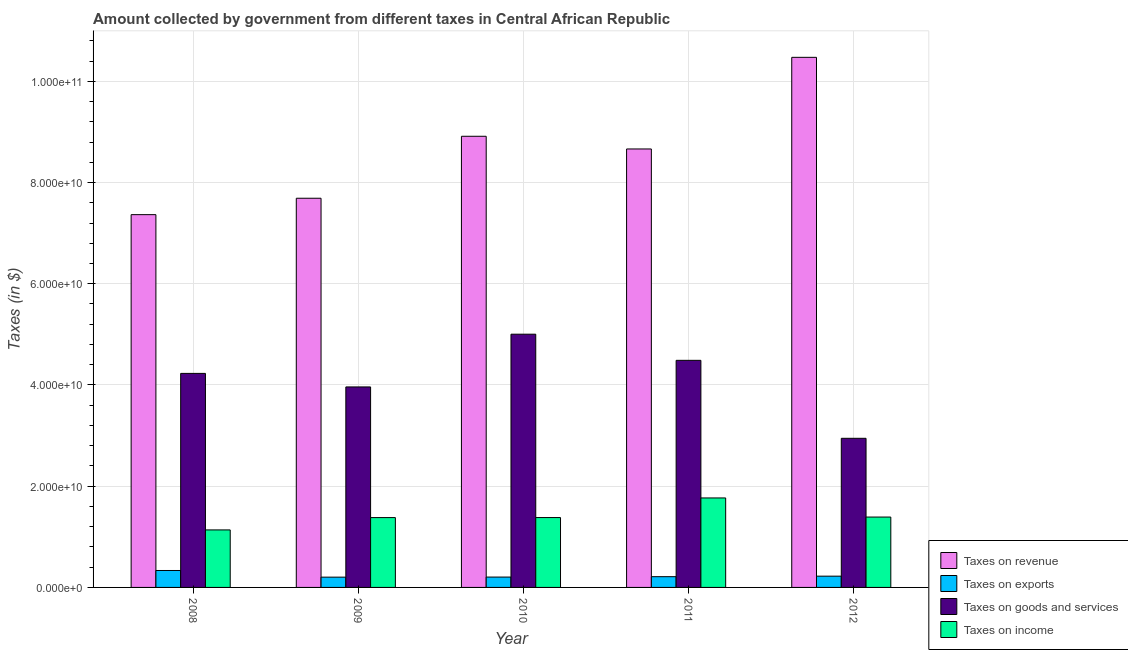How many bars are there on the 5th tick from the left?
Give a very brief answer. 4. How many bars are there on the 1st tick from the right?
Provide a succinct answer. 4. What is the label of the 4th group of bars from the left?
Your answer should be compact. 2011. In how many cases, is the number of bars for a given year not equal to the number of legend labels?
Your response must be concise. 0. What is the amount collected as tax on income in 2012?
Make the answer very short. 1.39e+1. Across all years, what is the maximum amount collected as tax on income?
Your answer should be very brief. 1.77e+1. Across all years, what is the minimum amount collected as tax on goods?
Offer a terse response. 2.95e+1. In which year was the amount collected as tax on goods maximum?
Your response must be concise. 2010. In which year was the amount collected as tax on goods minimum?
Provide a succinct answer. 2012. What is the total amount collected as tax on revenue in the graph?
Provide a succinct answer. 4.31e+11. What is the difference between the amount collected as tax on goods in 2008 and that in 2012?
Ensure brevity in your answer.  1.28e+1. What is the difference between the amount collected as tax on exports in 2008 and the amount collected as tax on revenue in 2010?
Your response must be concise. 1.30e+09. What is the average amount collected as tax on income per year?
Offer a very short reply. 1.41e+1. In the year 2011, what is the difference between the amount collected as tax on revenue and amount collected as tax on income?
Your response must be concise. 0. In how many years, is the amount collected as tax on exports greater than 76000000000 $?
Make the answer very short. 0. What is the ratio of the amount collected as tax on goods in 2011 to that in 2012?
Offer a very short reply. 1.52. Is the amount collected as tax on income in 2009 less than that in 2010?
Provide a short and direct response. Yes. What is the difference between the highest and the second highest amount collected as tax on revenue?
Make the answer very short. 1.56e+1. What is the difference between the highest and the lowest amount collected as tax on exports?
Offer a very short reply. 1.32e+09. What does the 1st bar from the left in 2009 represents?
Keep it short and to the point. Taxes on revenue. What does the 3rd bar from the right in 2010 represents?
Provide a short and direct response. Taxes on exports. Is it the case that in every year, the sum of the amount collected as tax on revenue and amount collected as tax on exports is greater than the amount collected as tax on goods?
Offer a terse response. Yes. How many bars are there?
Keep it short and to the point. 20. Are the values on the major ticks of Y-axis written in scientific E-notation?
Your response must be concise. Yes. Where does the legend appear in the graph?
Keep it short and to the point. Bottom right. How many legend labels are there?
Give a very brief answer. 4. What is the title of the graph?
Make the answer very short. Amount collected by government from different taxes in Central African Republic. Does "Austria" appear as one of the legend labels in the graph?
Provide a succinct answer. No. What is the label or title of the X-axis?
Your answer should be very brief. Year. What is the label or title of the Y-axis?
Provide a succinct answer. Taxes (in $). What is the Taxes (in $) in Taxes on revenue in 2008?
Offer a very short reply. 7.37e+1. What is the Taxes (in $) of Taxes on exports in 2008?
Your answer should be very brief. 3.35e+09. What is the Taxes (in $) in Taxes on goods and services in 2008?
Your response must be concise. 4.23e+1. What is the Taxes (in $) in Taxes on income in 2008?
Make the answer very short. 1.14e+1. What is the Taxes (in $) of Taxes on revenue in 2009?
Provide a short and direct response. 7.69e+1. What is the Taxes (in $) of Taxes on exports in 2009?
Your response must be concise. 2.03e+09. What is the Taxes (in $) of Taxes on goods and services in 2009?
Provide a short and direct response. 3.96e+1. What is the Taxes (in $) of Taxes on income in 2009?
Offer a terse response. 1.38e+1. What is the Taxes (in $) of Taxes on revenue in 2010?
Make the answer very short. 8.91e+1. What is the Taxes (in $) in Taxes on exports in 2010?
Your answer should be compact. 2.05e+09. What is the Taxes (in $) in Taxes on goods and services in 2010?
Give a very brief answer. 5.00e+1. What is the Taxes (in $) in Taxes on income in 2010?
Your answer should be compact. 1.38e+1. What is the Taxes (in $) in Taxes on revenue in 2011?
Offer a terse response. 8.66e+1. What is the Taxes (in $) of Taxes on exports in 2011?
Keep it short and to the point. 2.12e+09. What is the Taxes (in $) in Taxes on goods and services in 2011?
Provide a succinct answer. 4.49e+1. What is the Taxes (in $) of Taxes on income in 2011?
Your answer should be compact. 1.77e+1. What is the Taxes (in $) in Taxes on revenue in 2012?
Your answer should be compact. 1.05e+11. What is the Taxes (in $) of Taxes on exports in 2012?
Give a very brief answer. 2.23e+09. What is the Taxes (in $) of Taxes on goods and services in 2012?
Make the answer very short. 2.95e+1. What is the Taxes (in $) in Taxes on income in 2012?
Your answer should be very brief. 1.39e+1. Across all years, what is the maximum Taxes (in $) in Taxes on revenue?
Give a very brief answer. 1.05e+11. Across all years, what is the maximum Taxes (in $) of Taxes on exports?
Make the answer very short. 3.35e+09. Across all years, what is the maximum Taxes (in $) of Taxes on goods and services?
Your answer should be very brief. 5.00e+1. Across all years, what is the maximum Taxes (in $) of Taxes on income?
Ensure brevity in your answer.  1.77e+1. Across all years, what is the minimum Taxes (in $) of Taxes on revenue?
Offer a very short reply. 7.37e+1. Across all years, what is the minimum Taxes (in $) of Taxes on exports?
Provide a succinct answer. 2.03e+09. Across all years, what is the minimum Taxes (in $) in Taxes on goods and services?
Provide a succinct answer. 2.95e+1. Across all years, what is the minimum Taxes (in $) of Taxes on income?
Ensure brevity in your answer.  1.14e+1. What is the total Taxes (in $) of Taxes on revenue in the graph?
Keep it short and to the point. 4.31e+11. What is the total Taxes (in $) in Taxes on exports in the graph?
Your answer should be compact. 1.18e+1. What is the total Taxes (in $) of Taxes on goods and services in the graph?
Offer a very short reply. 2.06e+11. What is the total Taxes (in $) of Taxes on income in the graph?
Provide a succinct answer. 7.05e+1. What is the difference between the Taxes (in $) of Taxes on revenue in 2008 and that in 2009?
Your response must be concise. -3.24e+09. What is the difference between the Taxes (in $) of Taxes on exports in 2008 and that in 2009?
Your answer should be very brief. 1.32e+09. What is the difference between the Taxes (in $) in Taxes on goods and services in 2008 and that in 2009?
Your answer should be compact. 2.67e+09. What is the difference between the Taxes (in $) of Taxes on income in 2008 and that in 2009?
Your response must be concise. -2.44e+09. What is the difference between the Taxes (in $) of Taxes on revenue in 2008 and that in 2010?
Offer a terse response. -1.55e+1. What is the difference between the Taxes (in $) in Taxes on exports in 2008 and that in 2010?
Your answer should be compact. 1.30e+09. What is the difference between the Taxes (in $) in Taxes on goods and services in 2008 and that in 2010?
Keep it short and to the point. -7.75e+09. What is the difference between the Taxes (in $) of Taxes on income in 2008 and that in 2010?
Offer a very short reply. -2.44e+09. What is the difference between the Taxes (in $) in Taxes on revenue in 2008 and that in 2011?
Provide a succinct answer. -1.30e+1. What is the difference between the Taxes (in $) in Taxes on exports in 2008 and that in 2011?
Keep it short and to the point. 1.22e+09. What is the difference between the Taxes (in $) of Taxes on goods and services in 2008 and that in 2011?
Make the answer very short. -2.58e+09. What is the difference between the Taxes (in $) of Taxes on income in 2008 and that in 2011?
Make the answer very short. -6.32e+09. What is the difference between the Taxes (in $) in Taxes on revenue in 2008 and that in 2012?
Your response must be concise. -3.11e+1. What is the difference between the Taxes (in $) in Taxes on exports in 2008 and that in 2012?
Provide a short and direct response. 1.12e+09. What is the difference between the Taxes (in $) of Taxes on goods and services in 2008 and that in 2012?
Your answer should be compact. 1.28e+1. What is the difference between the Taxes (in $) of Taxes on income in 2008 and that in 2012?
Provide a short and direct response. -2.54e+09. What is the difference between the Taxes (in $) of Taxes on revenue in 2009 and that in 2010?
Your answer should be compact. -1.22e+1. What is the difference between the Taxes (in $) in Taxes on exports in 2009 and that in 2010?
Your answer should be very brief. -1.71e+07. What is the difference between the Taxes (in $) of Taxes on goods and services in 2009 and that in 2010?
Keep it short and to the point. -1.04e+1. What is the difference between the Taxes (in $) of Taxes on income in 2009 and that in 2010?
Ensure brevity in your answer.  -7.21e+06. What is the difference between the Taxes (in $) in Taxes on revenue in 2009 and that in 2011?
Your answer should be very brief. -9.74e+09. What is the difference between the Taxes (in $) of Taxes on exports in 2009 and that in 2011?
Your answer should be compact. -9.30e+07. What is the difference between the Taxes (in $) of Taxes on goods and services in 2009 and that in 2011?
Ensure brevity in your answer.  -5.25e+09. What is the difference between the Taxes (in $) in Taxes on income in 2009 and that in 2011?
Provide a short and direct response. -3.88e+09. What is the difference between the Taxes (in $) in Taxes on revenue in 2009 and that in 2012?
Provide a short and direct response. -2.78e+1. What is the difference between the Taxes (in $) in Taxes on exports in 2009 and that in 2012?
Make the answer very short. -1.96e+08. What is the difference between the Taxes (in $) in Taxes on goods and services in 2009 and that in 2012?
Make the answer very short. 1.02e+1. What is the difference between the Taxes (in $) in Taxes on income in 2009 and that in 2012?
Provide a short and direct response. -1.05e+08. What is the difference between the Taxes (in $) of Taxes on revenue in 2010 and that in 2011?
Offer a terse response. 2.50e+09. What is the difference between the Taxes (in $) in Taxes on exports in 2010 and that in 2011?
Provide a short and direct response. -7.59e+07. What is the difference between the Taxes (in $) in Taxes on goods and services in 2010 and that in 2011?
Your answer should be very brief. 5.16e+09. What is the difference between the Taxes (in $) in Taxes on income in 2010 and that in 2011?
Provide a short and direct response. -3.87e+09. What is the difference between the Taxes (in $) in Taxes on revenue in 2010 and that in 2012?
Your answer should be compact. -1.56e+1. What is the difference between the Taxes (in $) in Taxes on exports in 2010 and that in 2012?
Provide a short and direct response. -1.79e+08. What is the difference between the Taxes (in $) in Taxes on goods and services in 2010 and that in 2012?
Give a very brief answer. 2.06e+1. What is the difference between the Taxes (in $) of Taxes on income in 2010 and that in 2012?
Your answer should be very brief. -9.73e+07. What is the difference between the Taxes (in $) in Taxes on revenue in 2011 and that in 2012?
Keep it short and to the point. -1.81e+1. What is the difference between the Taxes (in $) in Taxes on exports in 2011 and that in 2012?
Make the answer very short. -1.03e+08. What is the difference between the Taxes (in $) of Taxes on goods and services in 2011 and that in 2012?
Your answer should be very brief. 1.54e+1. What is the difference between the Taxes (in $) in Taxes on income in 2011 and that in 2012?
Give a very brief answer. 3.78e+09. What is the difference between the Taxes (in $) of Taxes on revenue in 2008 and the Taxes (in $) of Taxes on exports in 2009?
Your answer should be compact. 7.16e+1. What is the difference between the Taxes (in $) of Taxes on revenue in 2008 and the Taxes (in $) of Taxes on goods and services in 2009?
Provide a succinct answer. 3.40e+1. What is the difference between the Taxes (in $) of Taxes on revenue in 2008 and the Taxes (in $) of Taxes on income in 2009?
Your answer should be compact. 5.99e+1. What is the difference between the Taxes (in $) in Taxes on exports in 2008 and the Taxes (in $) in Taxes on goods and services in 2009?
Your answer should be very brief. -3.63e+1. What is the difference between the Taxes (in $) in Taxes on exports in 2008 and the Taxes (in $) in Taxes on income in 2009?
Your answer should be compact. -1.05e+1. What is the difference between the Taxes (in $) in Taxes on goods and services in 2008 and the Taxes (in $) in Taxes on income in 2009?
Make the answer very short. 2.85e+1. What is the difference between the Taxes (in $) of Taxes on revenue in 2008 and the Taxes (in $) of Taxes on exports in 2010?
Provide a short and direct response. 7.16e+1. What is the difference between the Taxes (in $) of Taxes on revenue in 2008 and the Taxes (in $) of Taxes on goods and services in 2010?
Keep it short and to the point. 2.36e+1. What is the difference between the Taxes (in $) of Taxes on revenue in 2008 and the Taxes (in $) of Taxes on income in 2010?
Offer a very short reply. 5.98e+1. What is the difference between the Taxes (in $) in Taxes on exports in 2008 and the Taxes (in $) in Taxes on goods and services in 2010?
Offer a very short reply. -4.67e+1. What is the difference between the Taxes (in $) in Taxes on exports in 2008 and the Taxes (in $) in Taxes on income in 2010?
Give a very brief answer. -1.05e+1. What is the difference between the Taxes (in $) in Taxes on goods and services in 2008 and the Taxes (in $) in Taxes on income in 2010?
Give a very brief answer. 2.85e+1. What is the difference between the Taxes (in $) of Taxes on revenue in 2008 and the Taxes (in $) of Taxes on exports in 2011?
Offer a terse response. 7.15e+1. What is the difference between the Taxes (in $) in Taxes on revenue in 2008 and the Taxes (in $) in Taxes on goods and services in 2011?
Your response must be concise. 2.88e+1. What is the difference between the Taxes (in $) in Taxes on revenue in 2008 and the Taxes (in $) in Taxes on income in 2011?
Ensure brevity in your answer.  5.60e+1. What is the difference between the Taxes (in $) of Taxes on exports in 2008 and the Taxes (in $) of Taxes on goods and services in 2011?
Offer a terse response. -4.15e+1. What is the difference between the Taxes (in $) of Taxes on exports in 2008 and the Taxes (in $) of Taxes on income in 2011?
Offer a very short reply. -1.43e+1. What is the difference between the Taxes (in $) of Taxes on goods and services in 2008 and the Taxes (in $) of Taxes on income in 2011?
Give a very brief answer. 2.46e+1. What is the difference between the Taxes (in $) in Taxes on revenue in 2008 and the Taxes (in $) in Taxes on exports in 2012?
Keep it short and to the point. 7.14e+1. What is the difference between the Taxes (in $) in Taxes on revenue in 2008 and the Taxes (in $) in Taxes on goods and services in 2012?
Give a very brief answer. 4.42e+1. What is the difference between the Taxes (in $) of Taxes on revenue in 2008 and the Taxes (in $) of Taxes on income in 2012?
Provide a short and direct response. 5.97e+1. What is the difference between the Taxes (in $) of Taxes on exports in 2008 and the Taxes (in $) of Taxes on goods and services in 2012?
Offer a very short reply. -2.61e+1. What is the difference between the Taxes (in $) in Taxes on exports in 2008 and the Taxes (in $) in Taxes on income in 2012?
Offer a very short reply. -1.06e+1. What is the difference between the Taxes (in $) of Taxes on goods and services in 2008 and the Taxes (in $) of Taxes on income in 2012?
Keep it short and to the point. 2.84e+1. What is the difference between the Taxes (in $) of Taxes on revenue in 2009 and the Taxes (in $) of Taxes on exports in 2010?
Provide a short and direct response. 7.48e+1. What is the difference between the Taxes (in $) in Taxes on revenue in 2009 and the Taxes (in $) in Taxes on goods and services in 2010?
Your answer should be compact. 2.69e+1. What is the difference between the Taxes (in $) of Taxes on revenue in 2009 and the Taxes (in $) of Taxes on income in 2010?
Your response must be concise. 6.31e+1. What is the difference between the Taxes (in $) in Taxes on exports in 2009 and the Taxes (in $) in Taxes on goods and services in 2010?
Your answer should be very brief. -4.80e+1. What is the difference between the Taxes (in $) of Taxes on exports in 2009 and the Taxes (in $) of Taxes on income in 2010?
Keep it short and to the point. -1.18e+1. What is the difference between the Taxes (in $) of Taxes on goods and services in 2009 and the Taxes (in $) of Taxes on income in 2010?
Your answer should be very brief. 2.58e+1. What is the difference between the Taxes (in $) in Taxes on revenue in 2009 and the Taxes (in $) in Taxes on exports in 2011?
Your answer should be compact. 7.48e+1. What is the difference between the Taxes (in $) in Taxes on revenue in 2009 and the Taxes (in $) in Taxes on goods and services in 2011?
Keep it short and to the point. 3.20e+1. What is the difference between the Taxes (in $) in Taxes on revenue in 2009 and the Taxes (in $) in Taxes on income in 2011?
Make the answer very short. 5.92e+1. What is the difference between the Taxes (in $) in Taxes on exports in 2009 and the Taxes (in $) in Taxes on goods and services in 2011?
Offer a very short reply. -4.28e+1. What is the difference between the Taxes (in $) in Taxes on exports in 2009 and the Taxes (in $) in Taxes on income in 2011?
Provide a short and direct response. -1.56e+1. What is the difference between the Taxes (in $) in Taxes on goods and services in 2009 and the Taxes (in $) in Taxes on income in 2011?
Your response must be concise. 2.19e+1. What is the difference between the Taxes (in $) of Taxes on revenue in 2009 and the Taxes (in $) of Taxes on exports in 2012?
Keep it short and to the point. 7.47e+1. What is the difference between the Taxes (in $) in Taxes on revenue in 2009 and the Taxes (in $) in Taxes on goods and services in 2012?
Offer a terse response. 4.74e+1. What is the difference between the Taxes (in $) in Taxes on revenue in 2009 and the Taxes (in $) in Taxes on income in 2012?
Give a very brief answer. 6.30e+1. What is the difference between the Taxes (in $) in Taxes on exports in 2009 and the Taxes (in $) in Taxes on goods and services in 2012?
Ensure brevity in your answer.  -2.74e+1. What is the difference between the Taxes (in $) of Taxes on exports in 2009 and the Taxes (in $) of Taxes on income in 2012?
Provide a succinct answer. -1.19e+1. What is the difference between the Taxes (in $) of Taxes on goods and services in 2009 and the Taxes (in $) of Taxes on income in 2012?
Ensure brevity in your answer.  2.57e+1. What is the difference between the Taxes (in $) of Taxes on revenue in 2010 and the Taxes (in $) of Taxes on exports in 2011?
Offer a very short reply. 8.70e+1. What is the difference between the Taxes (in $) of Taxes on revenue in 2010 and the Taxes (in $) of Taxes on goods and services in 2011?
Make the answer very short. 4.43e+1. What is the difference between the Taxes (in $) of Taxes on revenue in 2010 and the Taxes (in $) of Taxes on income in 2011?
Give a very brief answer. 7.15e+1. What is the difference between the Taxes (in $) of Taxes on exports in 2010 and the Taxes (in $) of Taxes on goods and services in 2011?
Provide a succinct answer. -4.28e+1. What is the difference between the Taxes (in $) of Taxes on exports in 2010 and the Taxes (in $) of Taxes on income in 2011?
Provide a succinct answer. -1.56e+1. What is the difference between the Taxes (in $) of Taxes on goods and services in 2010 and the Taxes (in $) of Taxes on income in 2011?
Provide a succinct answer. 3.24e+1. What is the difference between the Taxes (in $) of Taxes on revenue in 2010 and the Taxes (in $) of Taxes on exports in 2012?
Keep it short and to the point. 8.69e+1. What is the difference between the Taxes (in $) in Taxes on revenue in 2010 and the Taxes (in $) in Taxes on goods and services in 2012?
Provide a succinct answer. 5.97e+1. What is the difference between the Taxes (in $) of Taxes on revenue in 2010 and the Taxes (in $) of Taxes on income in 2012?
Ensure brevity in your answer.  7.52e+1. What is the difference between the Taxes (in $) in Taxes on exports in 2010 and the Taxes (in $) in Taxes on goods and services in 2012?
Give a very brief answer. -2.74e+1. What is the difference between the Taxes (in $) in Taxes on exports in 2010 and the Taxes (in $) in Taxes on income in 2012?
Make the answer very short. -1.19e+1. What is the difference between the Taxes (in $) in Taxes on goods and services in 2010 and the Taxes (in $) in Taxes on income in 2012?
Your answer should be compact. 3.61e+1. What is the difference between the Taxes (in $) in Taxes on revenue in 2011 and the Taxes (in $) in Taxes on exports in 2012?
Keep it short and to the point. 8.44e+1. What is the difference between the Taxes (in $) of Taxes on revenue in 2011 and the Taxes (in $) of Taxes on goods and services in 2012?
Provide a succinct answer. 5.72e+1. What is the difference between the Taxes (in $) in Taxes on revenue in 2011 and the Taxes (in $) in Taxes on income in 2012?
Keep it short and to the point. 7.27e+1. What is the difference between the Taxes (in $) in Taxes on exports in 2011 and the Taxes (in $) in Taxes on goods and services in 2012?
Provide a short and direct response. -2.73e+1. What is the difference between the Taxes (in $) in Taxes on exports in 2011 and the Taxes (in $) in Taxes on income in 2012?
Provide a succinct answer. -1.18e+1. What is the difference between the Taxes (in $) in Taxes on goods and services in 2011 and the Taxes (in $) in Taxes on income in 2012?
Your response must be concise. 3.10e+1. What is the average Taxes (in $) in Taxes on revenue per year?
Provide a succinct answer. 8.62e+1. What is the average Taxes (in $) in Taxes on exports per year?
Provide a succinct answer. 2.35e+09. What is the average Taxes (in $) in Taxes on goods and services per year?
Ensure brevity in your answer.  4.13e+1. What is the average Taxes (in $) of Taxes on income per year?
Your response must be concise. 1.41e+1. In the year 2008, what is the difference between the Taxes (in $) in Taxes on revenue and Taxes (in $) in Taxes on exports?
Your answer should be very brief. 7.03e+1. In the year 2008, what is the difference between the Taxes (in $) of Taxes on revenue and Taxes (in $) of Taxes on goods and services?
Your answer should be compact. 3.14e+1. In the year 2008, what is the difference between the Taxes (in $) in Taxes on revenue and Taxes (in $) in Taxes on income?
Keep it short and to the point. 6.23e+1. In the year 2008, what is the difference between the Taxes (in $) in Taxes on exports and Taxes (in $) in Taxes on goods and services?
Keep it short and to the point. -3.89e+1. In the year 2008, what is the difference between the Taxes (in $) of Taxes on exports and Taxes (in $) of Taxes on income?
Offer a terse response. -8.02e+09. In the year 2008, what is the difference between the Taxes (in $) of Taxes on goods and services and Taxes (in $) of Taxes on income?
Your answer should be compact. 3.09e+1. In the year 2009, what is the difference between the Taxes (in $) in Taxes on revenue and Taxes (in $) in Taxes on exports?
Your answer should be compact. 7.49e+1. In the year 2009, what is the difference between the Taxes (in $) in Taxes on revenue and Taxes (in $) in Taxes on goods and services?
Make the answer very short. 3.73e+1. In the year 2009, what is the difference between the Taxes (in $) in Taxes on revenue and Taxes (in $) in Taxes on income?
Keep it short and to the point. 6.31e+1. In the year 2009, what is the difference between the Taxes (in $) of Taxes on exports and Taxes (in $) of Taxes on goods and services?
Your response must be concise. -3.76e+1. In the year 2009, what is the difference between the Taxes (in $) in Taxes on exports and Taxes (in $) in Taxes on income?
Offer a very short reply. -1.18e+1. In the year 2009, what is the difference between the Taxes (in $) in Taxes on goods and services and Taxes (in $) in Taxes on income?
Ensure brevity in your answer.  2.58e+1. In the year 2010, what is the difference between the Taxes (in $) of Taxes on revenue and Taxes (in $) of Taxes on exports?
Ensure brevity in your answer.  8.71e+1. In the year 2010, what is the difference between the Taxes (in $) of Taxes on revenue and Taxes (in $) of Taxes on goods and services?
Keep it short and to the point. 3.91e+1. In the year 2010, what is the difference between the Taxes (in $) in Taxes on revenue and Taxes (in $) in Taxes on income?
Your answer should be very brief. 7.53e+1. In the year 2010, what is the difference between the Taxes (in $) of Taxes on exports and Taxes (in $) of Taxes on goods and services?
Give a very brief answer. -4.80e+1. In the year 2010, what is the difference between the Taxes (in $) of Taxes on exports and Taxes (in $) of Taxes on income?
Make the answer very short. -1.18e+1. In the year 2010, what is the difference between the Taxes (in $) in Taxes on goods and services and Taxes (in $) in Taxes on income?
Offer a terse response. 3.62e+1. In the year 2011, what is the difference between the Taxes (in $) in Taxes on revenue and Taxes (in $) in Taxes on exports?
Offer a terse response. 8.45e+1. In the year 2011, what is the difference between the Taxes (in $) in Taxes on revenue and Taxes (in $) in Taxes on goods and services?
Make the answer very short. 4.18e+1. In the year 2011, what is the difference between the Taxes (in $) of Taxes on revenue and Taxes (in $) of Taxes on income?
Your response must be concise. 6.90e+1. In the year 2011, what is the difference between the Taxes (in $) of Taxes on exports and Taxes (in $) of Taxes on goods and services?
Provide a short and direct response. -4.27e+1. In the year 2011, what is the difference between the Taxes (in $) of Taxes on exports and Taxes (in $) of Taxes on income?
Provide a short and direct response. -1.56e+1. In the year 2011, what is the difference between the Taxes (in $) of Taxes on goods and services and Taxes (in $) of Taxes on income?
Provide a short and direct response. 2.72e+1. In the year 2012, what is the difference between the Taxes (in $) of Taxes on revenue and Taxes (in $) of Taxes on exports?
Make the answer very short. 1.03e+11. In the year 2012, what is the difference between the Taxes (in $) of Taxes on revenue and Taxes (in $) of Taxes on goods and services?
Ensure brevity in your answer.  7.53e+1. In the year 2012, what is the difference between the Taxes (in $) in Taxes on revenue and Taxes (in $) in Taxes on income?
Offer a very short reply. 9.08e+1. In the year 2012, what is the difference between the Taxes (in $) of Taxes on exports and Taxes (in $) of Taxes on goods and services?
Offer a very short reply. -2.72e+1. In the year 2012, what is the difference between the Taxes (in $) in Taxes on exports and Taxes (in $) in Taxes on income?
Keep it short and to the point. -1.17e+1. In the year 2012, what is the difference between the Taxes (in $) in Taxes on goods and services and Taxes (in $) in Taxes on income?
Your answer should be compact. 1.56e+1. What is the ratio of the Taxes (in $) in Taxes on revenue in 2008 to that in 2009?
Offer a very short reply. 0.96. What is the ratio of the Taxes (in $) of Taxes on exports in 2008 to that in 2009?
Your response must be concise. 1.65. What is the ratio of the Taxes (in $) of Taxes on goods and services in 2008 to that in 2009?
Your answer should be compact. 1.07. What is the ratio of the Taxes (in $) in Taxes on income in 2008 to that in 2009?
Your answer should be very brief. 0.82. What is the ratio of the Taxes (in $) of Taxes on revenue in 2008 to that in 2010?
Provide a succinct answer. 0.83. What is the ratio of the Taxes (in $) of Taxes on exports in 2008 to that in 2010?
Offer a very short reply. 1.63. What is the ratio of the Taxes (in $) of Taxes on goods and services in 2008 to that in 2010?
Provide a short and direct response. 0.85. What is the ratio of the Taxes (in $) in Taxes on income in 2008 to that in 2010?
Your answer should be very brief. 0.82. What is the ratio of the Taxes (in $) of Taxes on revenue in 2008 to that in 2011?
Your answer should be very brief. 0.85. What is the ratio of the Taxes (in $) in Taxes on exports in 2008 to that in 2011?
Your answer should be compact. 1.58. What is the ratio of the Taxes (in $) in Taxes on goods and services in 2008 to that in 2011?
Offer a terse response. 0.94. What is the ratio of the Taxes (in $) of Taxes on income in 2008 to that in 2011?
Ensure brevity in your answer.  0.64. What is the ratio of the Taxes (in $) of Taxes on revenue in 2008 to that in 2012?
Provide a succinct answer. 0.7. What is the ratio of the Taxes (in $) in Taxes on exports in 2008 to that in 2012?
Give a very brief answer. 1.5. What is the ratio of the Taxes (in $) of Taxes on goods and services in 2008 to that in 2012?
Your answer should be compact. 1.44. What is the ratio of the Taxes (in $) in Taxes on income in 2008 to that in 2012?
Your answer should be compact. 0.82. What is the ratio of the Taxes (in $) of Taxes on revenue in 2009 to that in 2010?
Ensure brevity in your answer.  0.86. What is the ratio of the Taxes (in $) of Taxes on goods and services in 2009 to that in 2010?
Give a very brief answer. 0.79. What is the ratio of the Taxes (in $) in Taxes on income in 2009 to that in 2010?
Ensure brevity in your answer.  1. What is the ratio of the Taxes (in $) of Taxes on revenue in 2009 to that in 2011?
Make the answer very short. 0.89. What is the ratio of the Taxes (in $) in Taxes on exports in 2009 to that in 2011?
Make the answer very short. 0.96. What is the ratio of the Taxes (in $) of Taxes on goods and services in 2009 to that in 2011?
Make the answer very short. 0.88. What is the ratio of the Taxes (in $) in Taxes on income in 2009 to that in 2011?
Your response must be concise. 0.78. What is the ratio of the Taxes (in $) in Taxes on revenue in 2009 to that in 2012?
Ensure brevity in your answer.  0.73. What is the ratio of the Taxes (in $) in Taxes on exports in 2009 to that in 2012?
Ensure brevity in your answer.  0.91. What is the ratio of the Taxes (in $) of Taxes on goods and services in 2009 to that in 2012?
Keep it short and to the point. 1.34. What is the ratio of the Taxes (in $) in Taxes on income in 2009 to that in 2012?
Offer a very short reply. 0.99. What is the ratio of the Taxes (in $) of Taxes on revenue in 2010 to that in 2011?
Keep it short and to the point. 1.03. What is the ratio of the Taxes (in $) of Taxes on goods and services in 2010 to that in 2011?
Give a very brief answer. 1.12. What is the ratio of the Taxes (in $) of Taxes on income in 2010 to that in 2011?
Offer a very short reply. 0.78. What is the ratio of the Taxes (in $) in Taxes on revenue in 2010 to that in 2012?
Make the answer very short. 0.85. What is the ratio of the Taxes (in $) of Taxes on exports in 2010 to that in 2012?
Ensure brevity in your answer.  0.92. What is the ratio of the Taxes (in $) in Taxes on goods and services in 2010 to that in 2012?
Offer a terse response. 1.7. What is the ratio of the Taxes (in $) in Taxes on income in 2010 to that in 2012?
Offer a terse response. 0.99. What is the ratio of the Taxes (in $) in Taxes on revenue in 2011 to that in 2012?
Make the answer very short. 0.83. What is the ratio of the Taxes (in $) of Taxes on exports in 2011 to that in 2012?
Offer a terse response. 0.95. What is the ratio of the Taxes (in $) in Taxes on goods and services in 2011 to that in 2012?
Make the answer very short. 1.52. What is the ratio of the Taxes (in $) in Taxes on income in 2011 to that in 2012?
Your answer should be compact. 1.27. What is the difference between the highest and the second highest Taxes (in $) of Taxes on revenue?
Your answer should be very brief. 1.56e+1. What is the difference between the highest and the second highest Taxes (in $) of Taxes on exports?
Offer a very short reply. 1.12e+09. What is the difference between the highest and the second highest Taxes (in $) in Taxes on goods and services?
Provide a short and direct response. 5.16e+09. What is the difference between the highest and the second highest Taxes (in $) of Taxes on income?
Provide a succinct answer. 3.78e+09. What is the difference between the highest and the lowest Taxes (in $) in Taxes on revenue?
Your answer should be very brief. 3.11e+1. What is the difference between the highest and the lowest Taxes (in $) in Taxes on exports?
Offer a very short reply. 1.32e+09. What is the difference between the highest and the lowest Taxes (in $) in Taxes on goods and services?
Offer a very short reply. 2.06e+1. What is the difference between the highest and the lowest Taxes (in $) of Taxes on income?
Keep it short and to the point. 6.32e+09. 